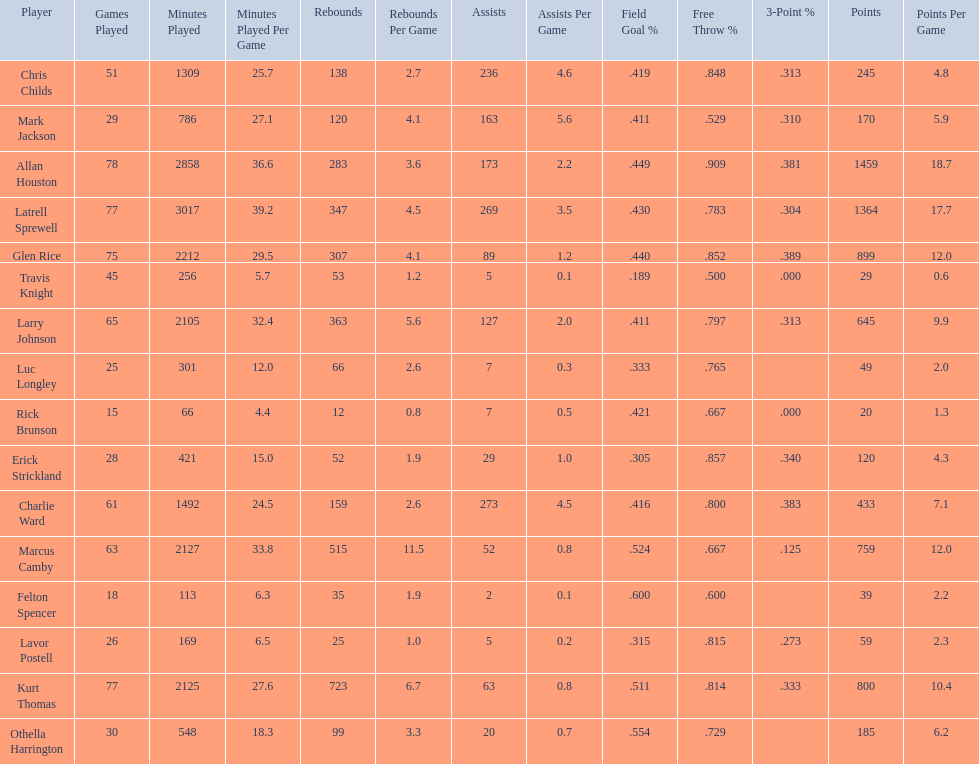Give the number of players covered by the table. 16. Can you give me this table as a dict? {'header': ['Player', 'Games Played', 'Minutes Played', 'Minutes Played Per Game', 'Rebounds', 'Rebounds Per Game', 'Assists', 'Assists Per Game', 'Field Goal\xa0%', 'Free Throw\xa0%', '3-Point\xa0%', 'Points', 'Points Per Game'], 'rows': [['Chris Childs', '51', '1309', '25.7', '138', '2.7', '236', '4.6', '.419', '.848', '.313', '245', '4.8'], ['Mark Jackson', '29', '786', '27.1', '120', '4.1', '163', '5.6', '.411', '.529', '.310', '170', '5.9'], ['Allan Houston', '78', '2858', '36.6', '283', '3.6', '173', '2.2', '.449', '.909', '.381', '1459', '18.7'], ['Latrell Sprewell', '77', '3017', '39.2', '347', '4.5', '269', '3.5', '.430', '.783', '.304', '1364', '17.7'], ['Glen Rice', '75', '2212', '29.5', '307', '4.1', '89', '1.2', '.440', '.852', '.389', '899', '12.0'], ['Travis Knight', '45', '256', '5.7', '53', '1.2', '5', '0.1', '.189', '.500', '.000', '29', '0.6'], ['Larry Johnson', '65', '2105', '32.4', '363', '5.6', '127', '2.0', '.411', '.797', '.313', '645', '9.9'], ['Luc Longley', '25', '301', '12.0', '66', '2.6', '7', '0.3', '.333', '.765', '', '49', '2.0'], ['Rick Brunson', '15', '66', '4.4', '12', '0.8', '7', '0.5', '.421', '.667', '.000', '20', '1.3'], ['Erick Strickland', '28', '421', '15.0', '52', '1.9', '29', '1.0', '.305', '.857', '.340', '120', '4.3'], ['Charlie Ward', '61', '1492', '24.5', '159', '2.6', '273', '4.5', '.416', '.800', '.383', '433', '7.1'], ['Marcus Camby', '63', '2127', '33.8', '515', '11.5', '52', '0.8', '.524', '.667', '.125', '759', '12.0'], ['Felton Spencer', '18', '113', '6.3', '35', '1.9', '2', '0.1', '.600', '.600', '', '39', '2.2'], ['Lavor Postell', '26', '169', '6.5', '25', '1.0', '5', '0.2', '.315', '.815', '.273', '59', '2.3'], ['Kurt Thomas', '77', '2125', '27.6', '723', '6.7', '63', '0.8', '.511', '.814', '.333', '800', '10.4'], ['Othella Harrington', '30', '548', '18.3', '99', '3.3', '20', '0.7', '.554', '.729', '', '185', '6.2']]} 